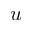Convert formula to latex. <formula><loc_0><loc_0><loc_500><loc_500>{ u }</formula> 